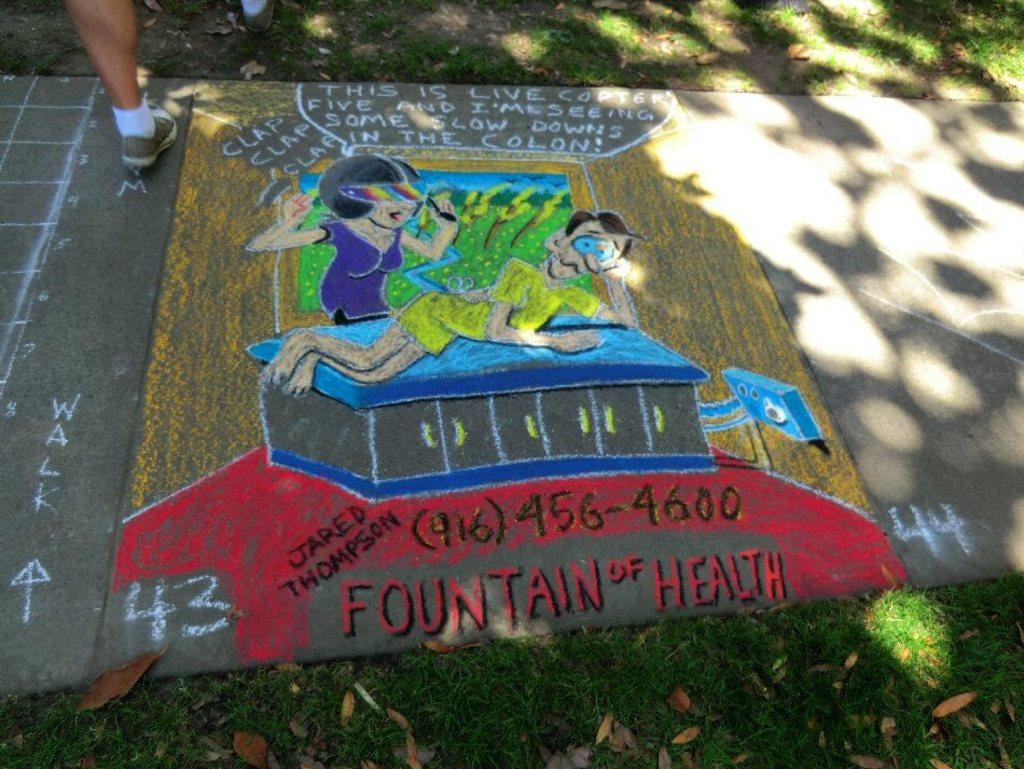How would you summarize this image in a sentence or two? In this image, we can see the painting on the ground, we can see the leg of a person. 